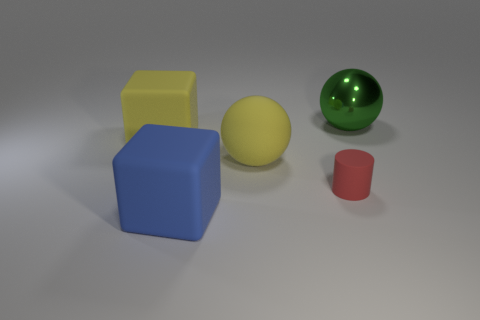Is there anything else that is made of the same material as the green sphere?
Provide a short and direct response. No. Is there any other thing that is the same shape as the small object?
Make the answer very short. No. There is a large rubber thing that is right of the cube in front of the big sphere in front of the large green metallic thing; what shape is it?
Offer a very short reply. Sphere. Are there an equal number of large metallic spheres left of the large blue matte block and small red metal spheres?
Your response must be concise. Yes. Is the yellow sphere the same size as the blue cube?
Your response must be concise. Yes. What number of rubber things are small cylinders or yellow objects?
Your answer should be compact. 3. What material is the green thing that is the same size as the yellow rubber block?
Provide a short and direct response. Metal. How many other things are there of the same material as the green sphere?
Provide a short and direct response. 0. Is the number of big metallic balls in front of the big yellow cube less than the number of small gray metallic cylinders?
Make the answer very short. No. Is the large green metal thing the same shape as the small matte thing?
Your response must be concise. No. 